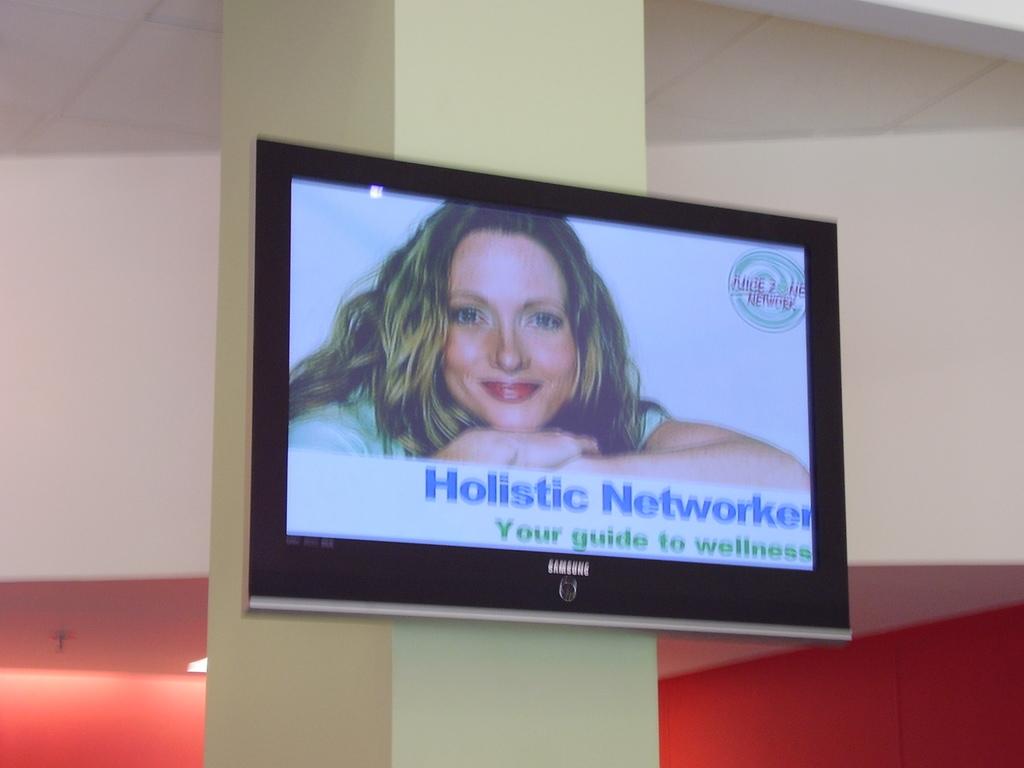What is the company in the ad?
Your answer should be compact. Holistic networker. Holistic networker is your guide to what?
Provide a short and direct response. Wellness. 